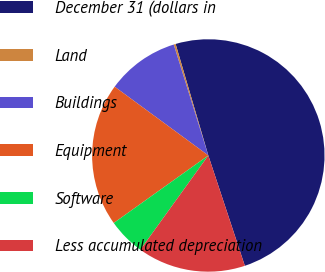<chart> <loc_0><loc_0><loc_500><loc_500><pie_chart><fcel>December 31 (dollars in<fcel>Land<fcel>Buildings<fcel>Equipment<fcel>Software<fcel>Less accumulated depreciation<nl><fcel>49.46%<fcel>0.27%<fcel>10.11%<fcel>19.95%<fcel>5.19%<fcel>15.03%<nl></chart> 